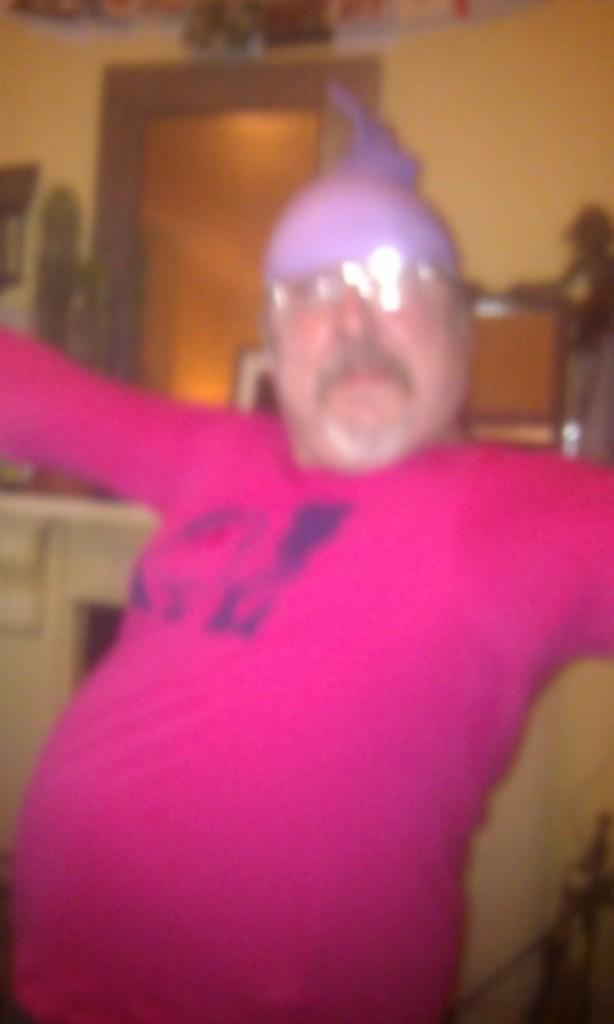What can be seen in the image? There is a person in the image. What is the person wearing? The person is wearing a pink t-shirt. How would you describe the quality of the image? The image is blurry. What type of leaf can be seen on the swing in the image? There is no leaf or swing present in the image; it only features a person wearing a pink t-shirt. 